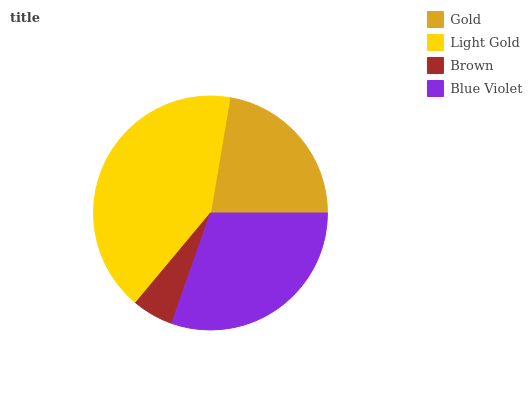Is Brown the minimum?
Answer yes or no. Yes. Is Light Gold the maximum?
Answer yes or no. Yes. Is Light Gold the minimum?
Answer yes or no. No. Is Brown the maximum?
Answer yes or no. No. Is Light Gold greater than Brown?
Answer yes or no. Yes. Is Brown less than Light Gold?
Answer yes or no. Yes. Is Brown greater than Light Gold?
Answer yes or no. No. Is Light Gold less than Brown?
Answer yes or no. No. Is Blue Violet the high median?
Answer yes or no. Yes. Is Gold the low median?
Answer yes or no. Yes. Is Light Gold the high median?
Answer yes or no. No. Is Light Gold the low median?
Answer yes or no. No. 